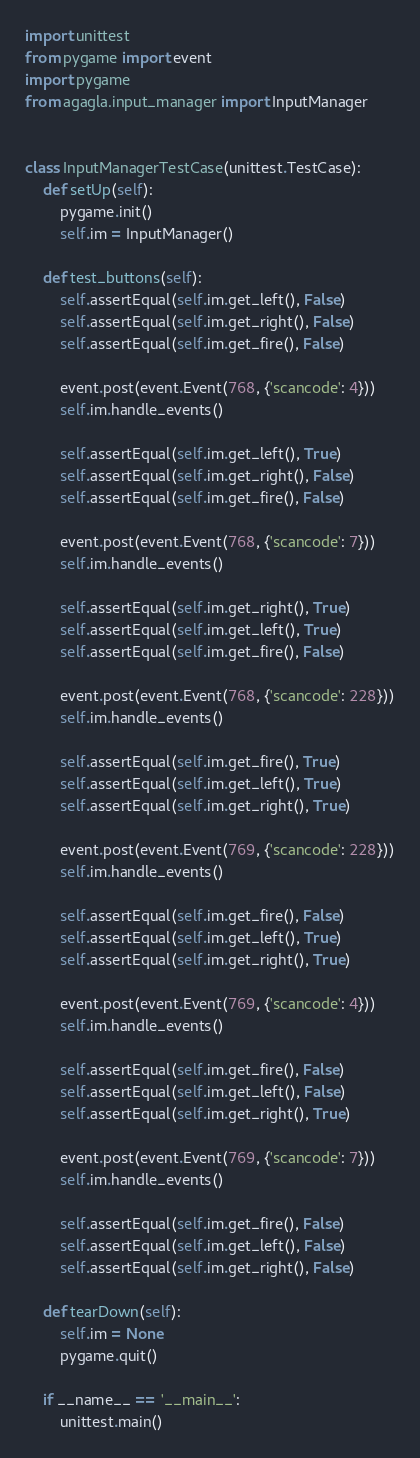<code> <loc_0><loc_0><loc_500><loc_500><_Python_>import unittest
from pygame import event
import pygame
from agagla.input_manager import InputManager


class InputManagerTestCase(unittest.TestCase):
    def setUp(self):
        pygame.init()
        self.im = InputManager()

    def test_buttons(self):
        self.assertEqual(self.im.get_left(), False)
        self.assertEqual(self.im.get_right(), False)
        self.assertEqual(self.im.get_fire(), False)

        event.post(event.Event(768, {'scancode': 4}))
        self.im.handle_events()

        self.assertEqual(self.im.get_left(), True)
        self.assertEqual(self.im.get_right(), False)
        self.assertEqual(self.im.get_fire(), False)

        event.post(event.Event(768, {'scancode': 7}))
        self.im.handle_events()

        self.assertEqual(self.im.get_right(), True)
        self.assertEqual(self.im.get_left(), True)
        self.assertEqual(self.im.get_fire(), False)

        event.post(event.Event(768, {'scancode': 228}))
        self.im.handle_events()

        self.assertEqual(self.im.get_fire(), True)
        self.assertEqual(self.im.get_left(), True)
        self.assertEqual(self.im.get_right(), True)

        event.post(event.Event(769, {'scancode': 228}))
        self.im.handle_events()

        self.assertEqual(self.im.get_fire(), False)
        self.assertEqual(self.im.get_left(), True)
        self.assertEqual(self.im.get_right(), True)

        event.post(event.Event(769, {'scancode': 4}))
        self.im.handle_events()

        self.assertEqual(self.im.get_fire(), False)
        self.assertEqual(self.im.get_left(), False)
        self.assertEqual(self.im.get_right(), True)

        event.post(event.Event(769, {'scancode': 7}))
        self.im.handle_events()

        self.assertEqual(self.im.get_fire(), False)
        self.assertEqual(self.im.get_left(), False)
        self.assertEqual(self.im.get_right(), False)

    def tearDown(self):
        self.im = None
        pygame.quit()

    if __name__ == '__main__':
        unittest.main()
</code> 